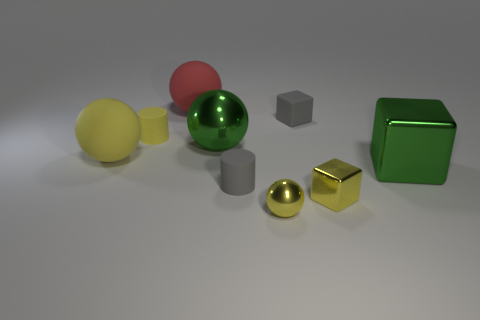Subtract all gray matte blocks. How many blocks are left? 2 Subtract all gray cubes. How many cubes are left? 2 Subtract 1 cylinders. How many cylinders are left? 1 Subtract all cylinders. How many objects are left? 7 Subtract all blue cylinders. How many green cubes are left? 1 Add 5 yellow balls. How many yellow balls are left? 7 Add 5 green objects. How many green objects exist? 7 Subtract 0 purple balls. How many objects are left? 9 Subtract all blue blocks. Subtract all cyan cylinders. How many blocks are left? 3 Subtract all rubber things. Subtract all tiny yellow spheres. How many objects are left? 3 